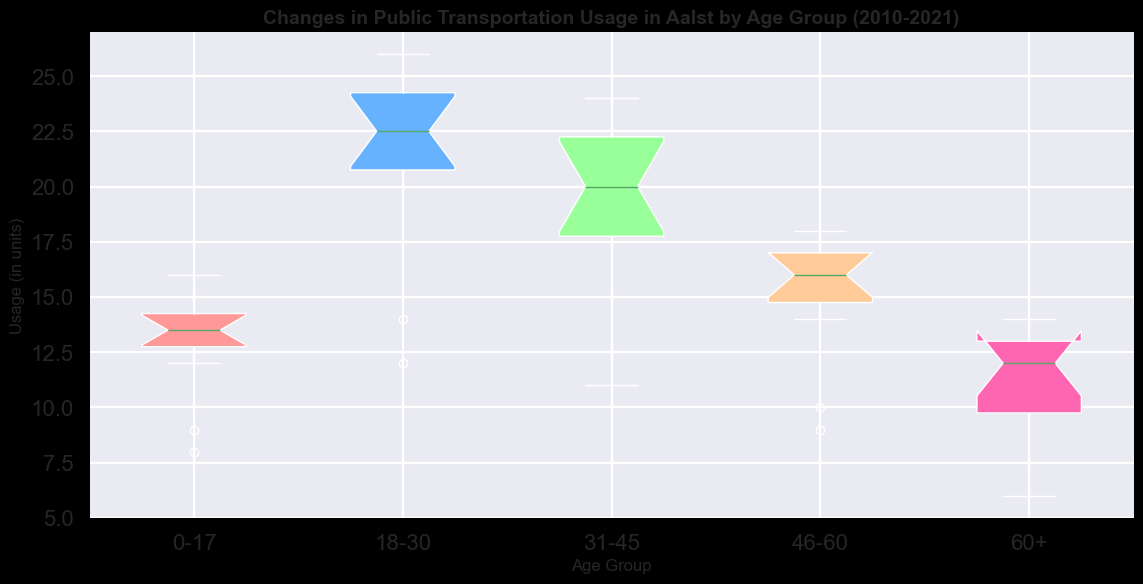What is the median public transportation usage for the 31-45 age group? The box plot will show the median line for each age group. Identify the median line within the interquartile range for the 31-45 age group.
Answer: 20 Which age group has the widest interquartile range in public transportation usage? The interquartile range (IQR) is represented by the height of the box in a box plot. Compare the height of the boxes for each age group to determine which one is the widest.
Answer: 18-30 How did the public transportation usage for the 0-17 age group change before and after 2018? Compare the box plot segments before (2010-2018) and after (2018-2021) for the 0-17 age group. Identify if there's a noticeable drop or increase in usage.
Answer: Decreased Which age group saw the largest drop in public transportation usage in 2020? Refer to the year 2020's marker or point on each box plot to see the usage by each age group in that particular year. Identify the age group with the largest drop compared to previous years.
Answer: 18-30 What is the color representing the 60+ age group? The question refers to the visual attribute of the color assigned to the 60+ age group. Identify the color used for the 60+ group's box plot.
Answer: Beige (or close to #FFCC99) Compare the median public transportation usage between 2010 and 2021 for the 46-60 age group. Identify the median lines for the 46-60 age group box plot for the years 2010 and 2021, respectively, and compare them.
Answer: Lower in 2021 What is the range of public transportation usage for the 18-30 age group? To find the range, identify the lowest and highest points (whiskers) in the 18-30 age group box plot and calculate the difference.
Answer: 12-26 Which age group has the most consistent public transportation usage over the years? Consistency can be determined by the smallest spread (range) and least variance in the box plot. Identify the age group box plot with the narrowest and most consistent distribution.
Answer: 60+ Did public transportation usage for the 60+ age group increase or decrease over the years? Examine the trend in the box plot for the 60+ age group from 2010 to 2021. Look at the median line and overall spread to determine the direction of the trend.
Answer: Increased till 2019, then decreased Which age group shows a notable outlier in the data? Outliers are often marked as individual points outside the whiskers in a box plot. Check each age group's box plot to identify the one with an outlier.
Answer: None 